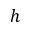Convert formula to latex. <formula><loc_0><loc_0><loc_500><loc_500>h</formula> 